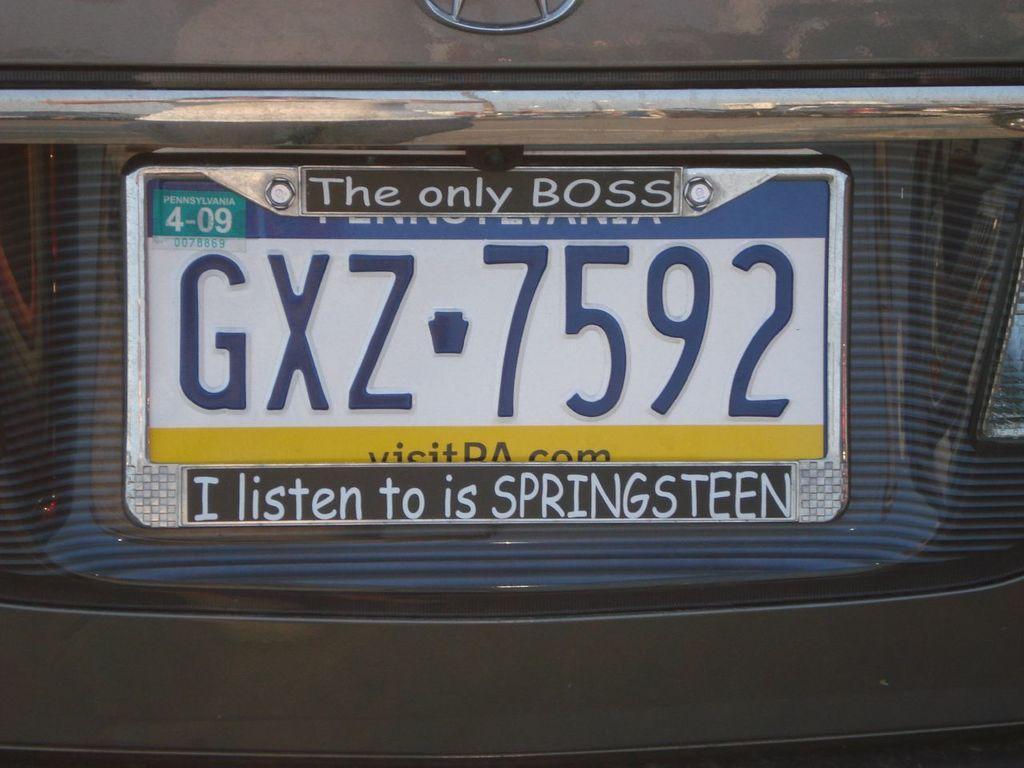Describe this image in one or two sentences. In this image, we can see a number plate of a vehicle. Here we can see some text. Top of the image, there is a logo. 